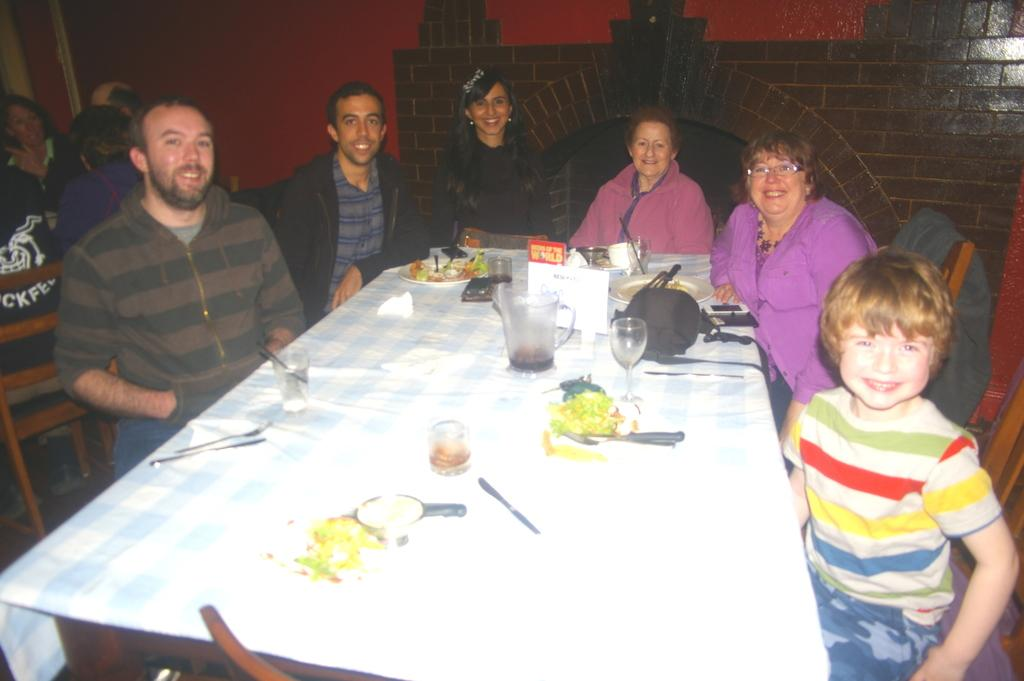Who is present in the image? There are people in the image. What are the people doing in the image? The people are sitting on chairs and having food. How are the people feeling in the image? The people are smiling in the image. What type of comb is being used by the people in the image? There is no comb present in the image; the people are having food and smiling. 